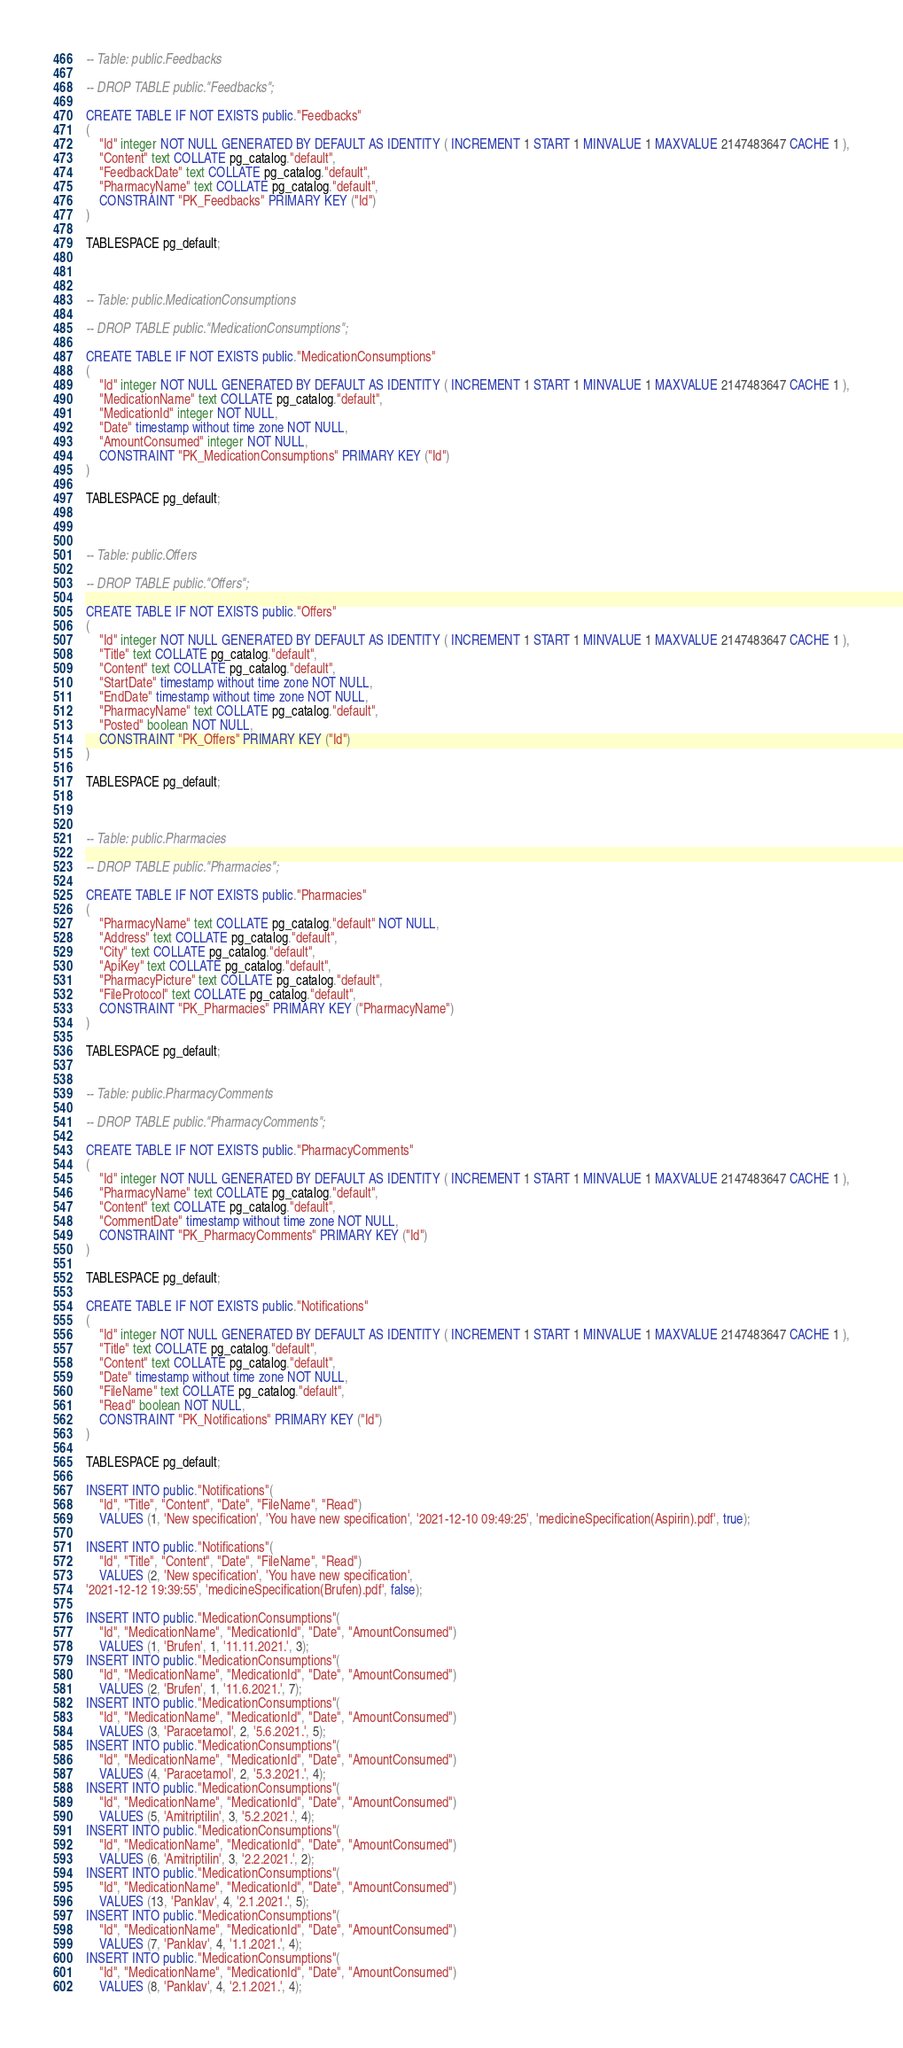Convert code to text. <code><loc_0><loc_0><loc_500><loc_500><_SQL_>-- Table: public.Feedbacks

-- DROP TABLE public."Feedbacks";

CREATE TABLE IF NOT EXISTS public."Feedbacks"
(
    "Id" integer NOT NULL GENERATED BY DEFAULT AS IDENTITY ( INCREMENT 1 START 1 MINVALUE 1 MAXVALUE 2147483647 CACHE 1 ),
    "Content" text COLLATE pg_catalog."default",
    "FeedbackDate" text COLLATE pg_catalog."default",
    "PharmacyName" text COLLATE pg_catalog."default",
    CONSTRAINT "PK_Feedbacks" PRIMARY KEY ("Id")
)

TABLESPACE pg_default;



-- Table: public.MedicationConsumptions

-- DROP TABLE public."MedicationConsumptions";

CREATE TABLE IF NOT EXISTS public."MedicationConsumptions"
(
    "Id" integer NOT NULL GENERATED BY DEFAULT AS IDENTITY ( INCREMENT 1 START 1 MINVALUE 1 MAXVALUE 2147483647 CACHE 1 ),
    "MedicationName" text COLLATE pg_catalog."default",
    "MedicationId" integer NOT NULL,
    "Date" timestamp without time zone NOT NULL,
    "AmountConsumed" integer NOT NULL,
    CONSTRAINT "PK_MedicationConsumptions" PRIMARY KEY ("Id")
)

TABLESPACE pg_default;



-- Table: public.Offers

-- DROP TABLE public."Offers";

CREATE TABLE IF NOT EXISTS public."Offers"
(
    "Id" integer NOT NULL GENERATED BY DEFAULT AS IDENTITY ( INCREMENT 1 START 1 MINVALUE 1 MAXVALUE 2147483647 CACHE 1 ),
    "Title" text COLLATE pg_catalog."default",
    "Content" text COLLATE pg_catalog."default",
    "StartDate" timestamp without time zone NOT NULL,
    "EndDate" timestamp without time zone NOT NULL,
    "PharmacyName" text COLLATE pg_catalog."default",
    "Posted" boolean NOT NULL,
    CONSTRAINT "PK_Offers" PRIMARY KEY ("Id")
)

TABLESPACE pg_default;



-- Table: public.Pharmacies

-- DROP TABLE public."Pharmacies";

CREATE TABLE IF NOT EXISTS public."Pharmacies"
(
    "PharmacyName" text COLLATE pg_catalog."default" NOT NULL,
    "Address" text COLLATE pg_catalog."default",
    "City" text COLLATE pg_catalog."default",
    "ApiKey" text COLLATE pg_catalog."default",
    "PharmacyPicture" text COLLATE pg_catalog."default",
    "FileProtocol" text COLLATE pg_catalog."default",
    CONSTRAINT "PK_Pharmacies" PRIMARY KEY ("PharmacyName")
)

TABLESPACE pg_default;


-- Table: public.PharmacyComments

-- DROP TABLE public."PharmacyComments";

CREATE TABLE IF NOT EXISTS public."PharmacyComments"
(
    "Id" integer NOT NULL GENERATED BY DEFAULT AS IDENTITY ( INCREMENT 1 START 1 MINVALUE 1 MAXVALUE 2147483647 CACHE 1 ),
    "PharmacyName" text COLLATE pg_catalog."default",
    "Content" text COLLATE pg_catalog."default",
    "CommentDate" timestamp without time zone NOT NULL,
    CONSTRAINT "PK_PharmacyComments" PRIMARY KEY ("Id")
)

TABLESPACE pg_default;

CREATE TABLE IF NOT EXISTS public."Notifications"
(
    "Id" integer NOT NULL GENERATED BY DEFAULT AS IDENTITY ( INCREMENT 1 START 1 MINVALUE 1 MAXVALUE 2147483647 CACHE 1 ),
    "Title" text COLLATE pg_catalog."default",
    "Content" text COLLATE pg_catalog."default",
    "Date" timestamp without time zone NOT NULL,
    "FileName" text COLLATE pg_catalog."default",
    "Read" boolean NOT NULL,
    CONSTRAINT "PK_Notifications" PRIMARY KEY ("Id")
)

TABLESPACE pg_default;

INSERT INTO public."Notifications"(
	"Id", "Title", "Content", "Date", "FileName", "Read")
	VALUES (1, 'New specification', 'You have new specification', '2021-12-10 09:49:25', 'medicineSpecification(Aspirin).pdf', true);

INSERT INTO public."Notifications"(
	"Id", "Title", "Content", "Date", "FileName", "Read")
	VALUES (2, 'New specification', 'You have new specification', 
'2021-12-12 19:39:55', 'medicineSpecification(Brufen).pdf', false);

INSERT INTO public."MedicationConsumptions"(
	"Id", "MedicationName", "MedicationId", "Date", "AmountConsumed")
	VALUES (1, 'Brufen', 1, '11.11.2021.', 3);
INSERT INTO public."MedicationConsumptions"(
	"Id", "MedicationName", "MedicationId", "Date", "AmountConsumed")
	VALUES (2, 'Brufen', 1, '11.6.2021.', 7);
INSERT INTO public."MedicationConsumptions"(
	"Id", "MedicationName", "MedicationId", "Date", "AmountConsumed")
	VALUES (3, 'Paracetamol', 2, '5.6.2021.', 5);
INSERT INTO public."MedicationConsumptions"(
	"Id", "MedicationName", "MedicationId", "Date", "AmountConsumed")
	VALUES (4, 'Paracetamol', 2, '5.3.2021.', 4);
INSERT INTO public."MedicationConsumptions"(
	"Id", "MedicationName", "MedicationId", "Date", "AmountConsumed")
	VALUES (5, 'Amitriptilin', 3, '5.2.2021.', 4);
INSERT INTO public."MedicationConsumptions"(
	"Id", "MedicationName", "MedicationId", "Date", "AmountConsumed")
	VALUES (6, 'Amitriptilin', 3, '2.2.2021.', 2);
INSERT INTO public."MedicationConsumptions"(
	"Id", "MedicationName", "MedicationId", "Date", "AmountConsumed")
	VALUES (13, 'Panklav', 4, '2.1.2021.', 5);
INSERT INTO public."MedicationConsumptions"(
	"Id", "MedicationName", "MedicationId", "Date", "AmountConsumed")
	VALUES (7, 'Panklav', 4, '1.1.2021.', 4);
INSERT INTO public."MedicationConsumptions"(
	"Id", "MedicationName", "MedicationId", "Date", "AmountConsumed")
	VALUES (8, 'Panklav', 4, '2.1.2021.', 4);</code> 